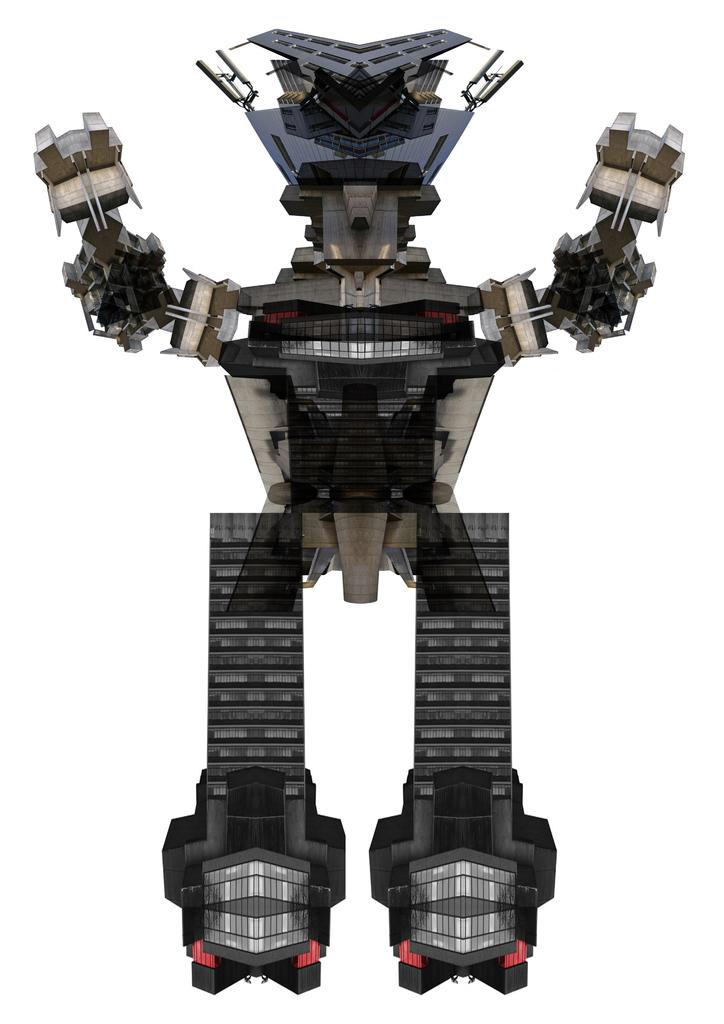What is the main subject of the image? There is a robot in the image. Where can the pets be seen playing with the drum in the harbor in the image? There are no pets, drums, or harbors present in the image; it features a robot. 